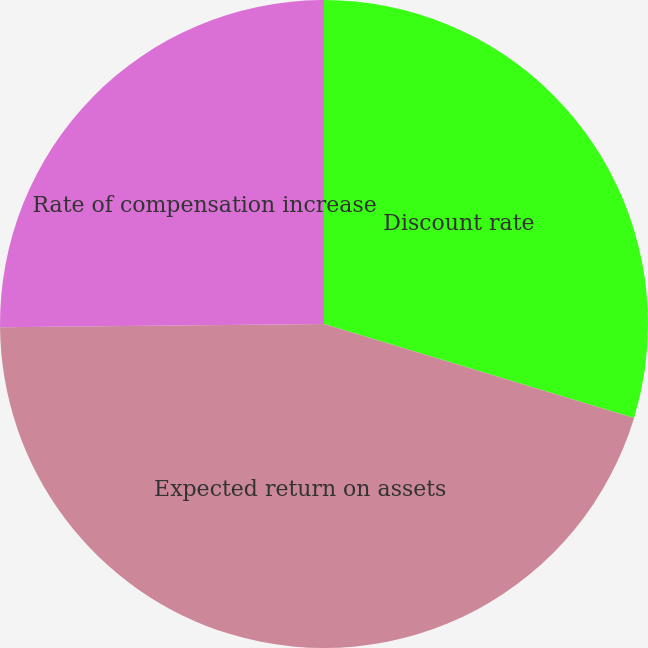Convert chart to OTSL. <chart><loc_0><loc_0><loc_500><loc_500><pie_chart><fcel>Discount rate<fcel>Expected return on assets<fcel>Rate of compensation increase<nl><fcel>29.68%<fcel>45.16%<fcel>25.16%<nl></chart> 